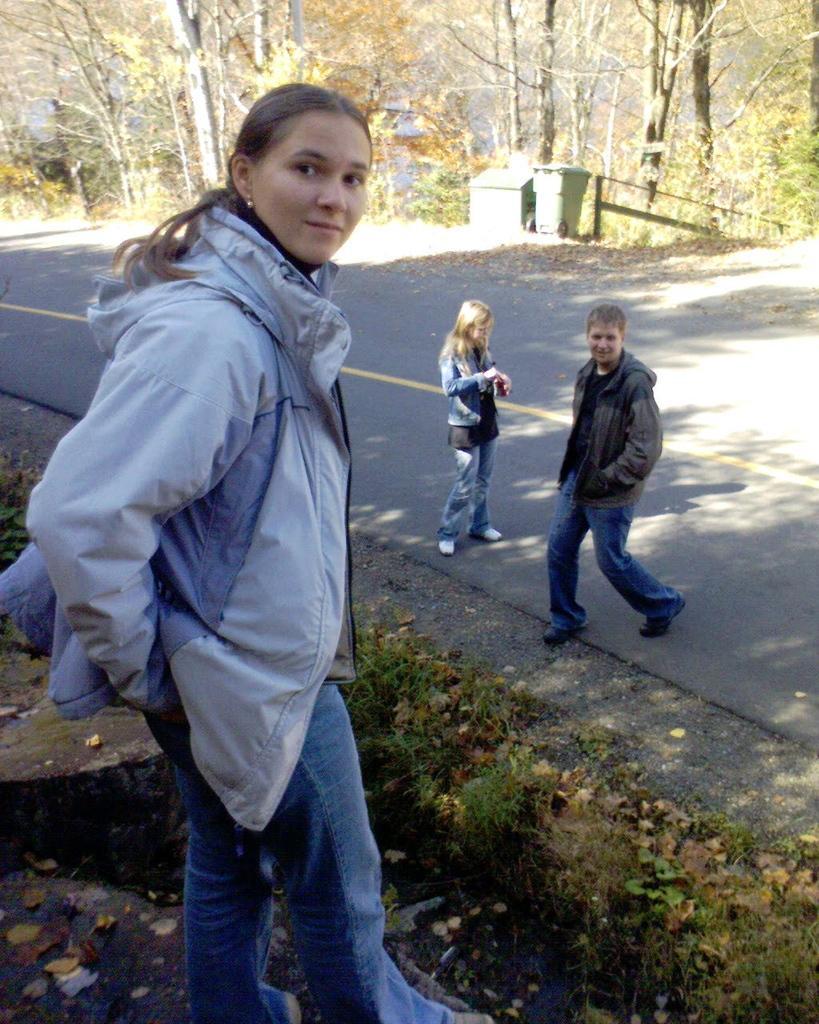Please provide a concise description of this image. In this picture there is a lady on the left side of the image and there is a girl and a boy in the image, there are trees and dustbins in the background area of the image. 